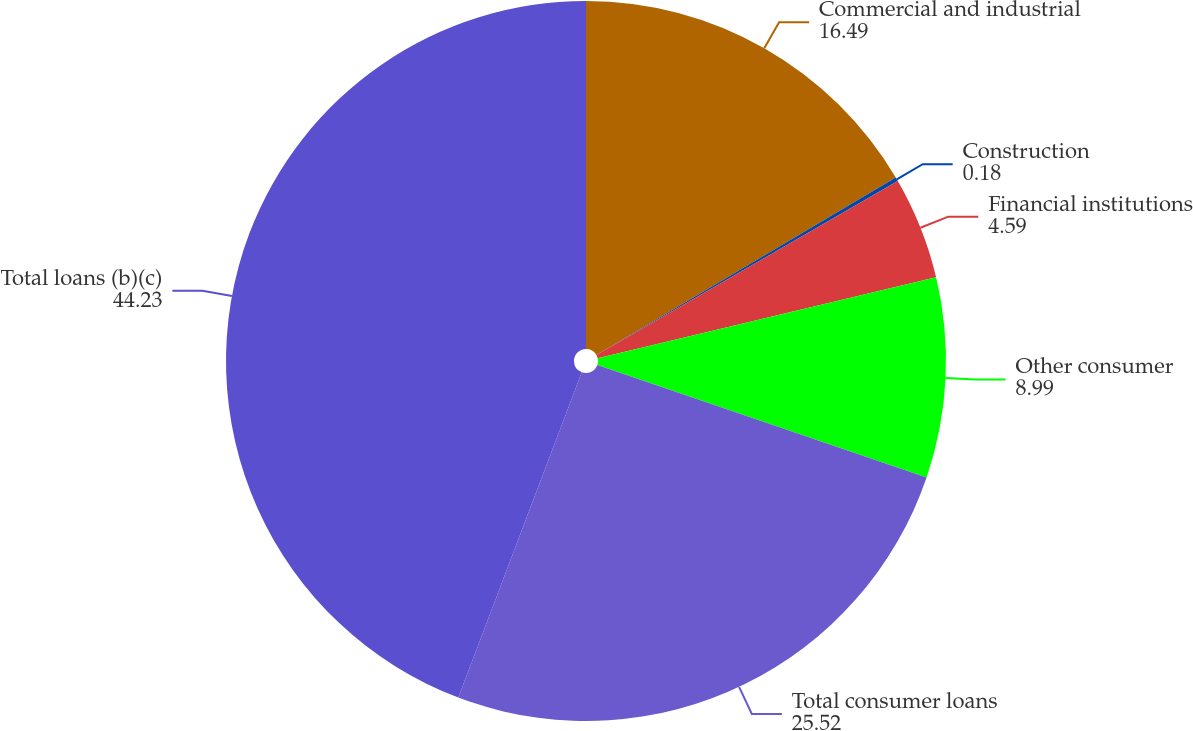Convert chart. <chart><loc_0><loc_0><loc_500><loc_500><pie_chart><fcel>Commercial and industrial<fcel>Construction<fcel>Financial institutions<fcel>Other consumer<fcel>Total consumer loans<fcel>Total loans (b)(c)<nl><fcel>16.49%<fcel>0.18%<fcel>4.59%<fcel>8.99%<fcel>25.52%<fcel>44.23%<nl></chart> 